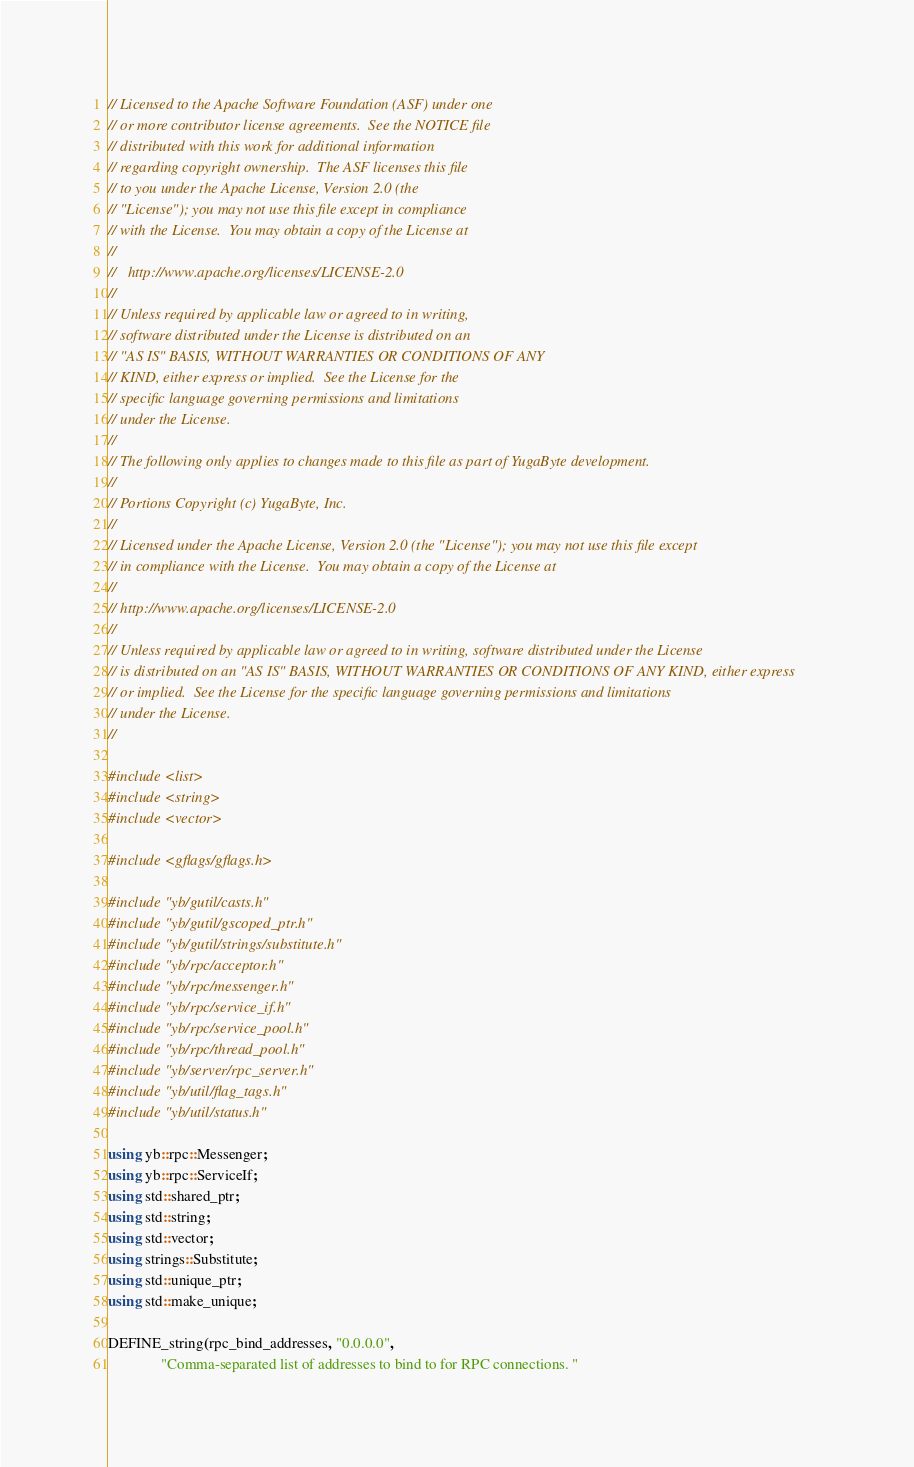Convert code to text. <code><loc_0><loc_0><loc_500><loc_500><_C++_>// Licensed to the Apache Software Foundation (ASF) under one
// or more contributor license agreements.  See the NOTICE file
// distributed with this work for additional information
// regarding copyright ownership.  The ASF licenses this file
// to you under the Apache License, Version 2.0 (the
// "License"); you may not use this file except in compliance
// with the License.  You may obtain a copy of the License at
//
//   http://www.apache.org/licenses/LICENSE-2.0
//
// Unless required by applicable law or agreed to in writing,
// software distributed under the License is distributed on an
// "AS IS" BASIS, WITHOUT WARRANTIES OR CONDITIONS OF ANY
// KIND, either express or implied.  See the License for the
// specific language governing permissions and limitations
// under the License.
//
// The following only applies to changes made to this file as part of YugaByte development.
//
// Portions Copyright (c) YugaByte, Inc.
//
// Licensed under the Apache License, Version 2.0 (the "License"); you may not use this file except
// in compliance with the License.  You may obtain a copy of the License at
//
// http://www.apache.org/licenses/LICENSE-2.0
//
// Unless required by applicable law or agreed to in writing, software distributed under the License
// is distributed on an "AS IS" BASIS, WITHOUT WARRANTIES OR CONDITIONS OF ANY KIND, either express
// or implied.  See the License for the specific language governing permissions and limitations
// under the License.
//

#include <list>
#include <string>
#include <vector>

#include <gflags/gflags.h>

#include "yb/gutil/casts.h"
#include "yb/gutil/gscoped_ptr.h"
#include "yb/gutil/strings/substitute.h"
#include "yb/rpc/acceptor.h"
#include "yb/rpc/messenger.h"
#include "yb/rpc/service_if.h"
#include "yb/rpc/service_pool.h"
#include "yb/rpc/thread_pool.h"
#include "yb/server/rpc_server.h"
#include "yb/util/flag_tags.h"
#include "yb/util/status.h"

using yb::rpc::Messenger;
using yb::rpc::ServiceIf;
using std::shared_ptr;
using std::string;
using std::vector;
using strings::Substitute;
using std::unique_ptr;
using std::make_unique;

DEFINE_string(rpc_bind_addresses, "0.0.0.0",
              "Comma-separated list of addresses to bind to for RPC connections. "</code> 